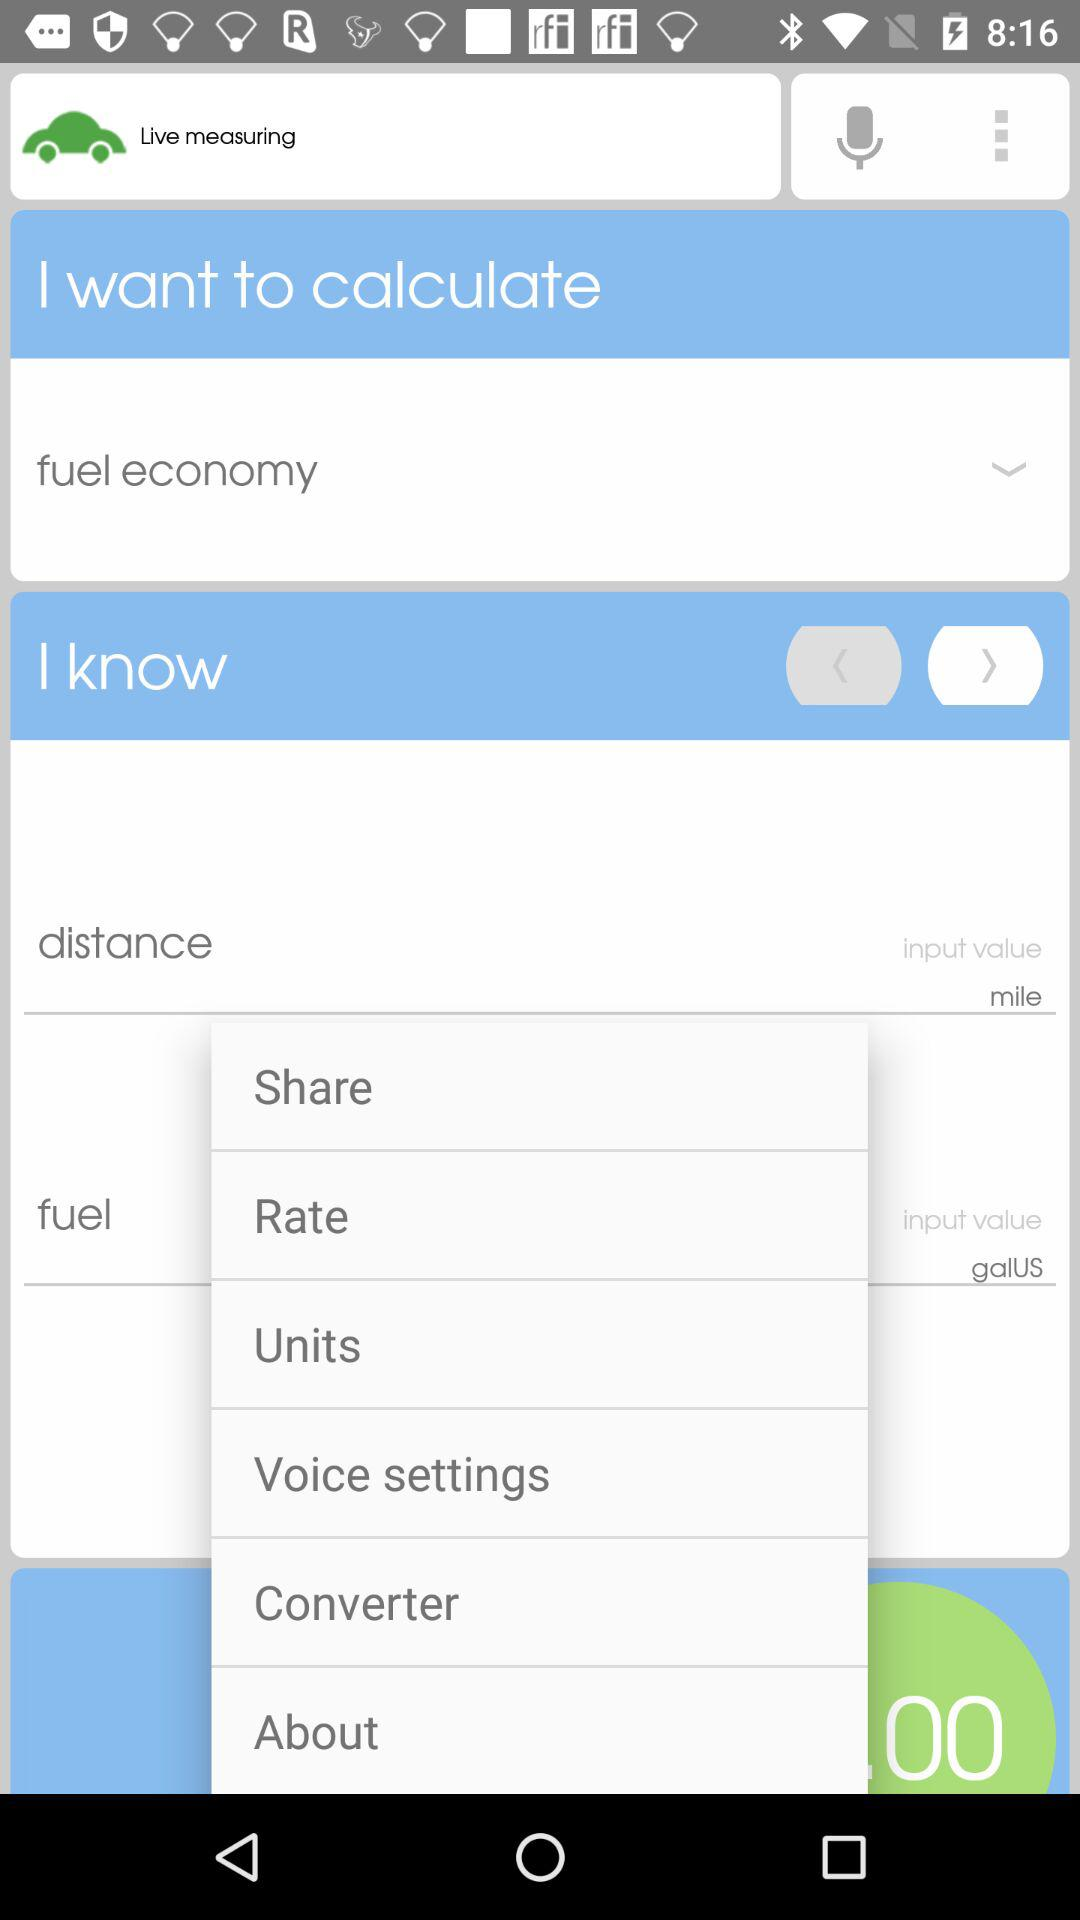How many input values are there on the screen?
Answer the question using a single word or phrase. 2 